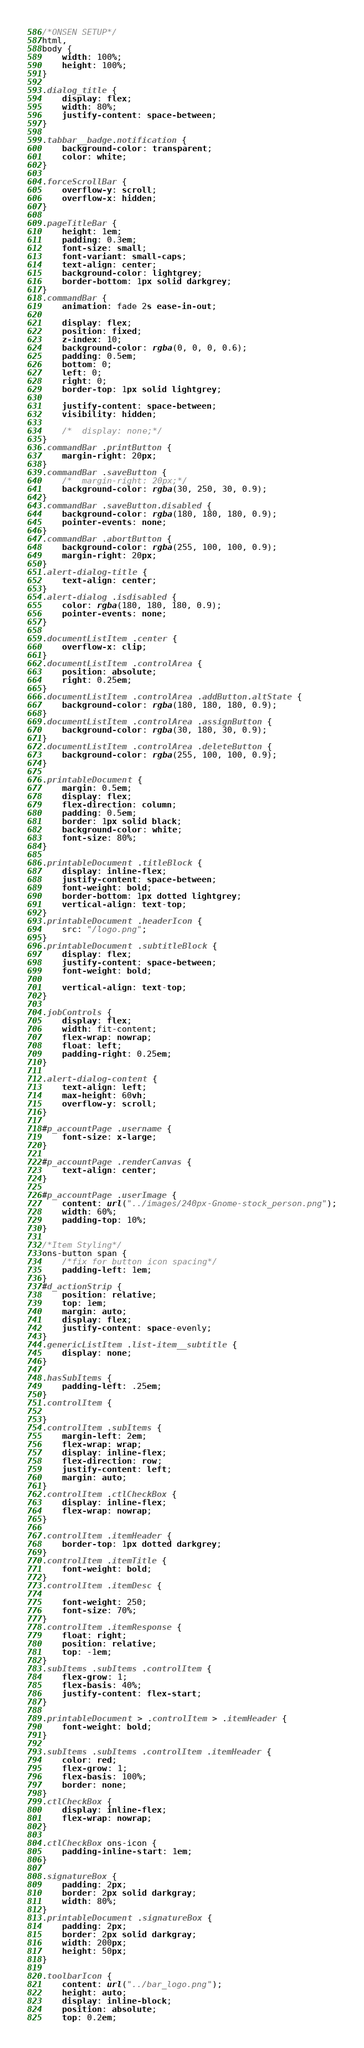Convert code to text. <code><loc_0><loc_0><loc_500><loc_500><_CSS_>/*ONSEN SETUP*/
html,
body {
	width: 100%;
	height: 100%;
}

.dialog_title {
	display: flex;
	width: 80%;
	justify-content: space-between;
}

.tabbar__badge.notification {
	background-color: transparent;
	color: white;
}

.forceScrollBar {
	overflow-y: scroll;
	overflow-x: hidden;
}

.pageTitleBar {
	height: 1em;
	padding: 0.3em;
	font-size: small;
	font-variant: small-caps;
	text-align: center;
	background-color: lightgrey;
	border-bottom: 1px solid darkgrey;
}
.commandBar {
	animation: fade 2s ease-in-out;

	display: flex;
	position: fixed;
	z-index: 10;
	background-color: rgba(0, 0, 0, 0.6);
	padding: 0.5em;
	bottom: 0;
	left: 0;
	right: 0;
	border-top: 1px solid lightgrey;

	justify-content: space-between;
	visibility: hidden;

	/*	display: none;*/
}
.commandBar .printButton {
	margin-right: 20px;
}
.commandBar .saveButton {
	/*	margin-right: 20px;*/
	background-color: rgba(30, 250, 30, 0.9);
}
.commandBar .saveButton.disabled {
	background-color: rgba(180, 180, 180, 0.9);
	pointer-events: none;
}
.commandBar .abortButton {
	background-color: rgba(255, 100, 100, 0.9);
	margin-right: 20px;
}
.alert-dialog-title {
	text-align: center;
}
.alert-dialog .isdisabled {
	color: rgba(180, 180, 180, 0.9);
	pointer-events: none;
}

.documentListItem .center {
	overflow-x: clip;
}
.documentListItem .controlArea {
	position: absolute;
	right: 0.25em;
}
.documentListItem .controlArea .addButton.altState {
	background-color: rgba(180, 180, 180, 0.9);
}
.documentListItem .controlArea .assignButton {
	background-color: rgba(30, 180, 30, 0.9);
}
.documentListItem .controlArea .deleteButton {
	background-color: rgba(255, 100, 100, 0.9);
}

.printableDocument {
	margin: 0.5em;
	display: flex;
	flex-direction: column;
	padding: 0.5em;
	border: 1px solid black;
	background-color: white;
	font-size: 80%;
}

.printableDocument .titleBlock {
	display: inline-flex;
	justify-content: space-between;
	font-weight: bold;
	border-bottom: 1px dotted lightgrey;
	vertical-align: text-top;
}
.printableDocument .headerIcon {
	src: "/logo.png";
}
.printableDocument .subtitleBlock {
	display: flex;
	justify-content: space-between;
	font-weight: bold;

	vertical-align: text-top;
}

.jobControls {
	display: flex;
	width: fit-content;
	flex-wrap: nowrap;
	float: left;
	padding-right: 0.25em;
}

.alert-dialog-content {
	text-align: left;
	max-height: 60vh;
	overflow-y: scroll;
}

#p_accountPage .username {
	font-size: x-large;
}

#p_accountPage .renderCanvas {
	text-align: center;
}

#p_accountPage .userImage {
	content: url("../images/240px-Gnome-stock_person.png");
	width: 60%;
	padding-top: 10%;
}

/*Item Styling*/
ons-button span {
	/*fix for button icon spacing*/
	padding-left: 1em;
}
#d_actionStrip {
	position: relative;
	top: 1em;
	margin: auto;
	display: flex;
	justify-content: space-evenly;
}
.genericListItem .list-item__subtitle {
	display: none;
}

.hasSubItems {
	padding-left: .25em;
}
.controlItem {

}
.controlItem .subItems {
	margin-left: 2em;
	flex-wrap: wrap;
	display: inline-flex;
	flex-direction: row;
	justify-content: left;
	margin: auto;
}
.controlItem .ctlCheckBox {
	display: inline-flex;
	flex-wrap: nowrap;
}

.controlItem .itemHeader {
	border-top: 1px dotted darkgrey;
}
.controlItem .itemTitle {
	font-weight: bold;
}
.controlItem .itemDesc {

	font-weight: 250;
	font-size: 70%;
}
.controlItem .itemResponse {
	float: right;
	position: relative;
	top: -1em;
}
.subItems .subItems .controlItem {
	flex-grow: 1;
	flex-basis: 40%;
	justify-content: flex-start;
}

.printableDocument > .controlItem > .itemHeader {
	font-weight: bold;
}

.subItems .subItems .controlItem .itemHeader {
	color: red;
	flex-grow: 1;
	flex-basis: 100%;
	border: none;
}
.ctlCheckBox {
	display: inline-flex;
	flex-wrap: nowrap;
}

.ctlCheckBox ons-icon {
	padding-inline-start: 1em;
}

.signatureBox {
	padding: 2px;
	border: 2px solid darkgray;
	width: 80%;
}
.printableDocument .signatureBox {
	padding: 2px;
	border: 2px solid darkgray;
	width: 200px;
	height: 50px;
}

.toolbarIcon {
	content: url("../bar_logo.png");
	height: auto;
	display: inline-block;
	position: absolute;
	top: 0.2em;</code> 